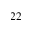<formula> <loc_0><loc_0><loc_500><loc_500>2 2</formula> 